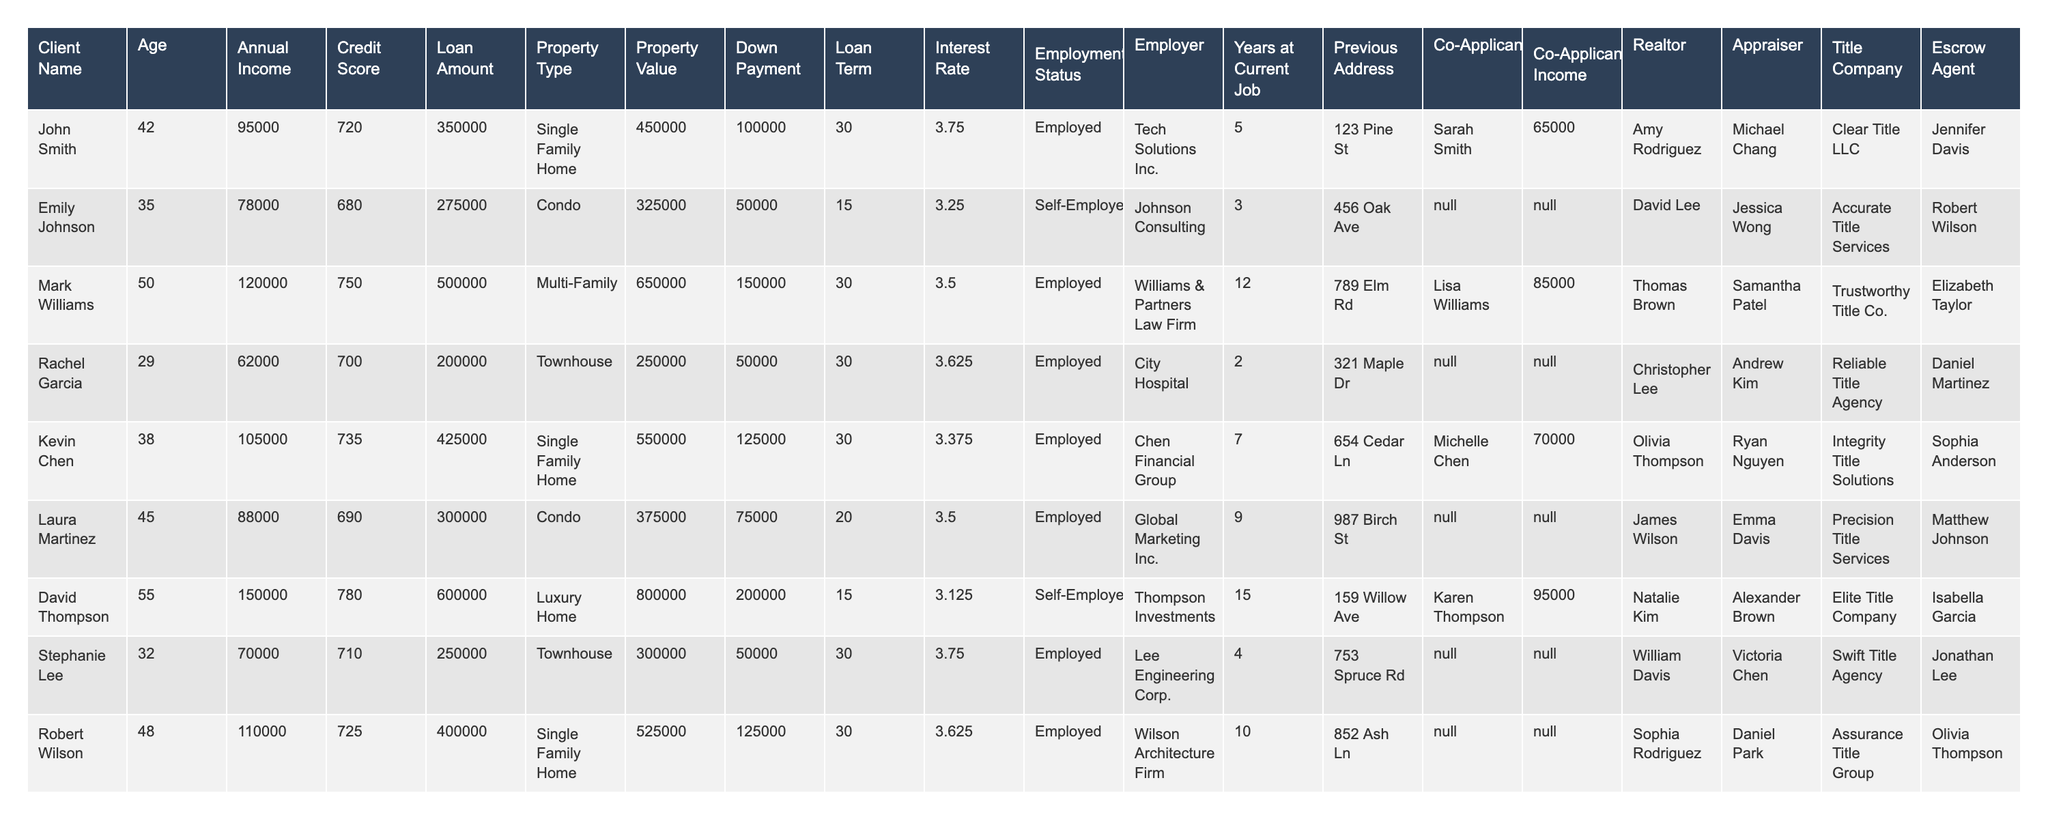What is the loan amount for Mark Williams? The loan amount is specified in the column titled "Loan Amount." For Mark Williams, the corresponding entry shows 500000.
Answer: 500000 What is the property value of the condo owned by Laura Martinez? The property value can be found in the "Property Value" column next to Laura Martinez's name, which shows 375000.
Answer: 375000 Who has the highest credit score in the table? By scanning the "Credit Score" column, David Thompson has the highest score of 780.
Answer: David Thompson What is the average loan amount for clients with a Credit Score above 700? First, identify the clients with a Credit Score above 700: John Smith (350000), Mark Williams (500000), David Thompson (600000), Kevin Chen (425000), Robert Wilson (400000). Then, sum them up (350000 + 500000 + 600000 + 425000 + 400000 = 2275000) and divide by the number of clients (5), which gives an average of 455000.
Answer: 455000 Is Emily Johnson self-employed? The "Employment Status" column clearly indicates whether a person is employed or self-employed. Emily Johnson is listed as "Self-Employed."
Answer: Yes What is the difference between Laura Martinez's annual income and David Thompson's annual income? Check the "Annual Income" column: Laura Martinez has an income of 88000, and David Thompson has an income of 150000. The difference is calculated as 150000 - 88000 = 62000.
Answer: 62000 How many clients are employed at a hospital or law firm? Review the "Employer" column to find clients working at a hospital (Rachel Garcia) and a law firm (Mark Williams) which totals to 2 clients.
Answer: 2 What is the total down payment made by the clients who own single-family homes? Locate the clients with single-family homes: John Smith (100000), Kevin Chen (125000), and Robert Wilson (125000). The total down payment is calculated as 100000 + 125000 + 125000 = 350000.
Answer: 350000 Which realtor is associated with Amanda Brown? In the "Realtor" column, Amanda Brown is associated with Benjamin Lee.
Answer: Benjamin Lee Is there a co-applicant for Sarah Smith? Check the "Co-Applicant" column next to Sarah Smith's entry, which states "N/A," indicating there is no co-applicant.
Answer: No 